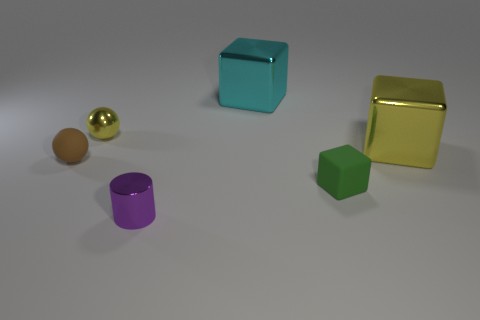Add 2 large red shiny cubes. How many objects exist? 8 Subtract all spheres. How many objects are left? 4 Add 3 large cyan cylinders. How many large cyan cylinders exist? 3 Subtract 1 purple cylinders. How many objects are left? 5 Subtract all metal cylinders. Subtract all big blue spheres. How many objects are left? 5 Add 6 small purple metallic cylinders. How many small purple metallic cylinders are left? 7 